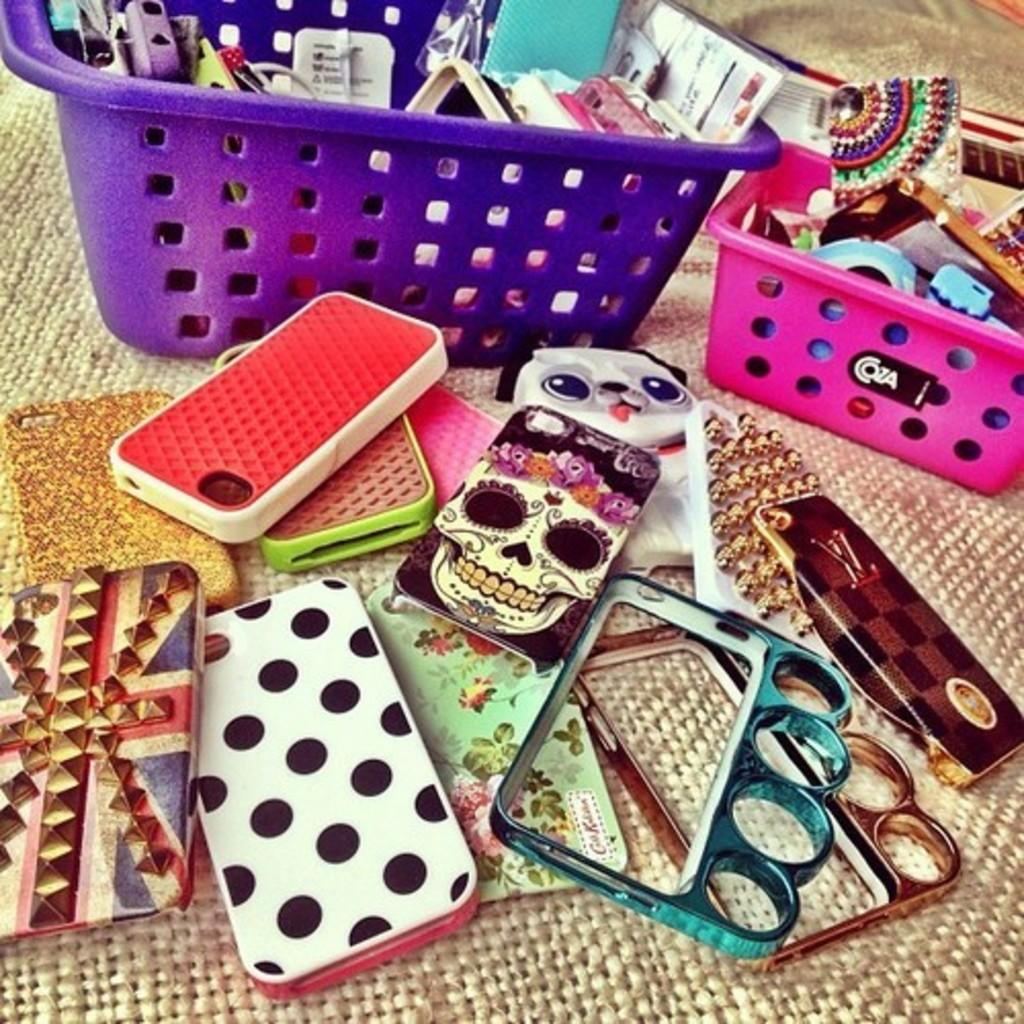What objects are on a mat in the foreground of the image? There are phone cases on a mat in the foreground of the image. Can you describe the objects in the background of the image? There are two baskets containing phone cases in the background of the image. What type of tooth can be seen in the image? There is no tooth present in the image. Is there a lawyer in the image? There is no lawyer present in the image. 